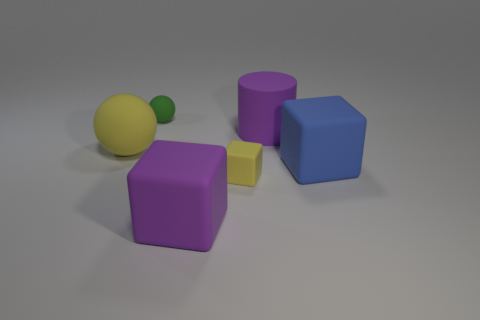Are all the objects in the image solids or are some of them hollow? It's impossible to determine if the objects are hollow or solid just from the image alone, but typically such geometric shapes depicted in visual problems are considered solid. 